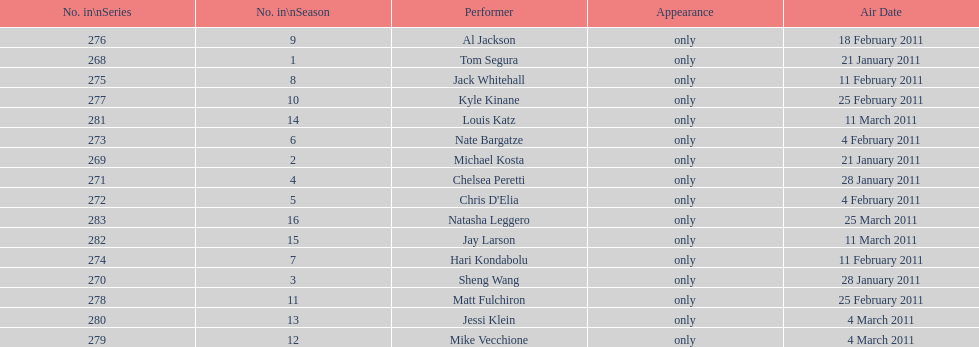What were the total number of air dates in february? 7. 